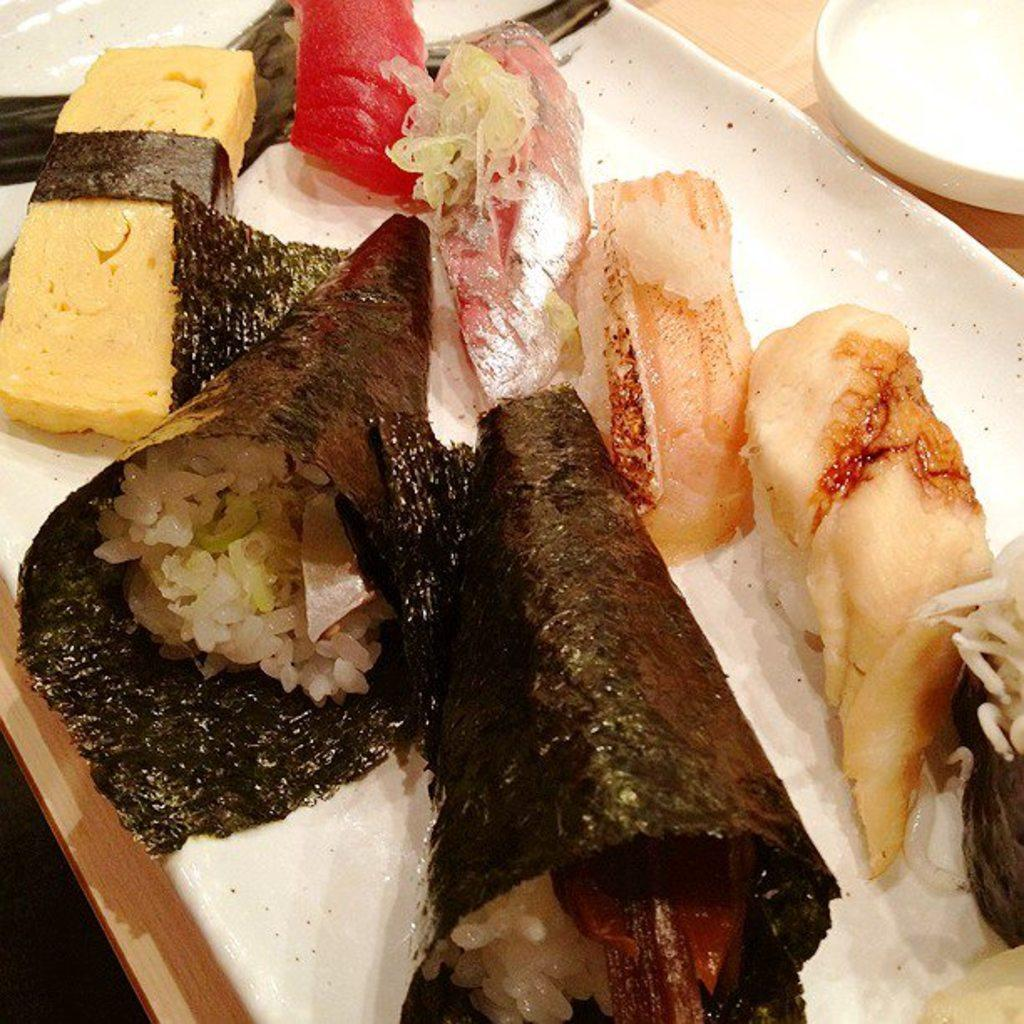What is on the plate in the image? There are food items in a plate in the image. What else can be seen on the table in the image? There are other objects on the table in the image. What type of farm animals can be seen on the table in the image? There are no farm animals present on the table in the image. How many points are visible on the plate in the image? There are no points visible on the plate in the image; it contains food items. 